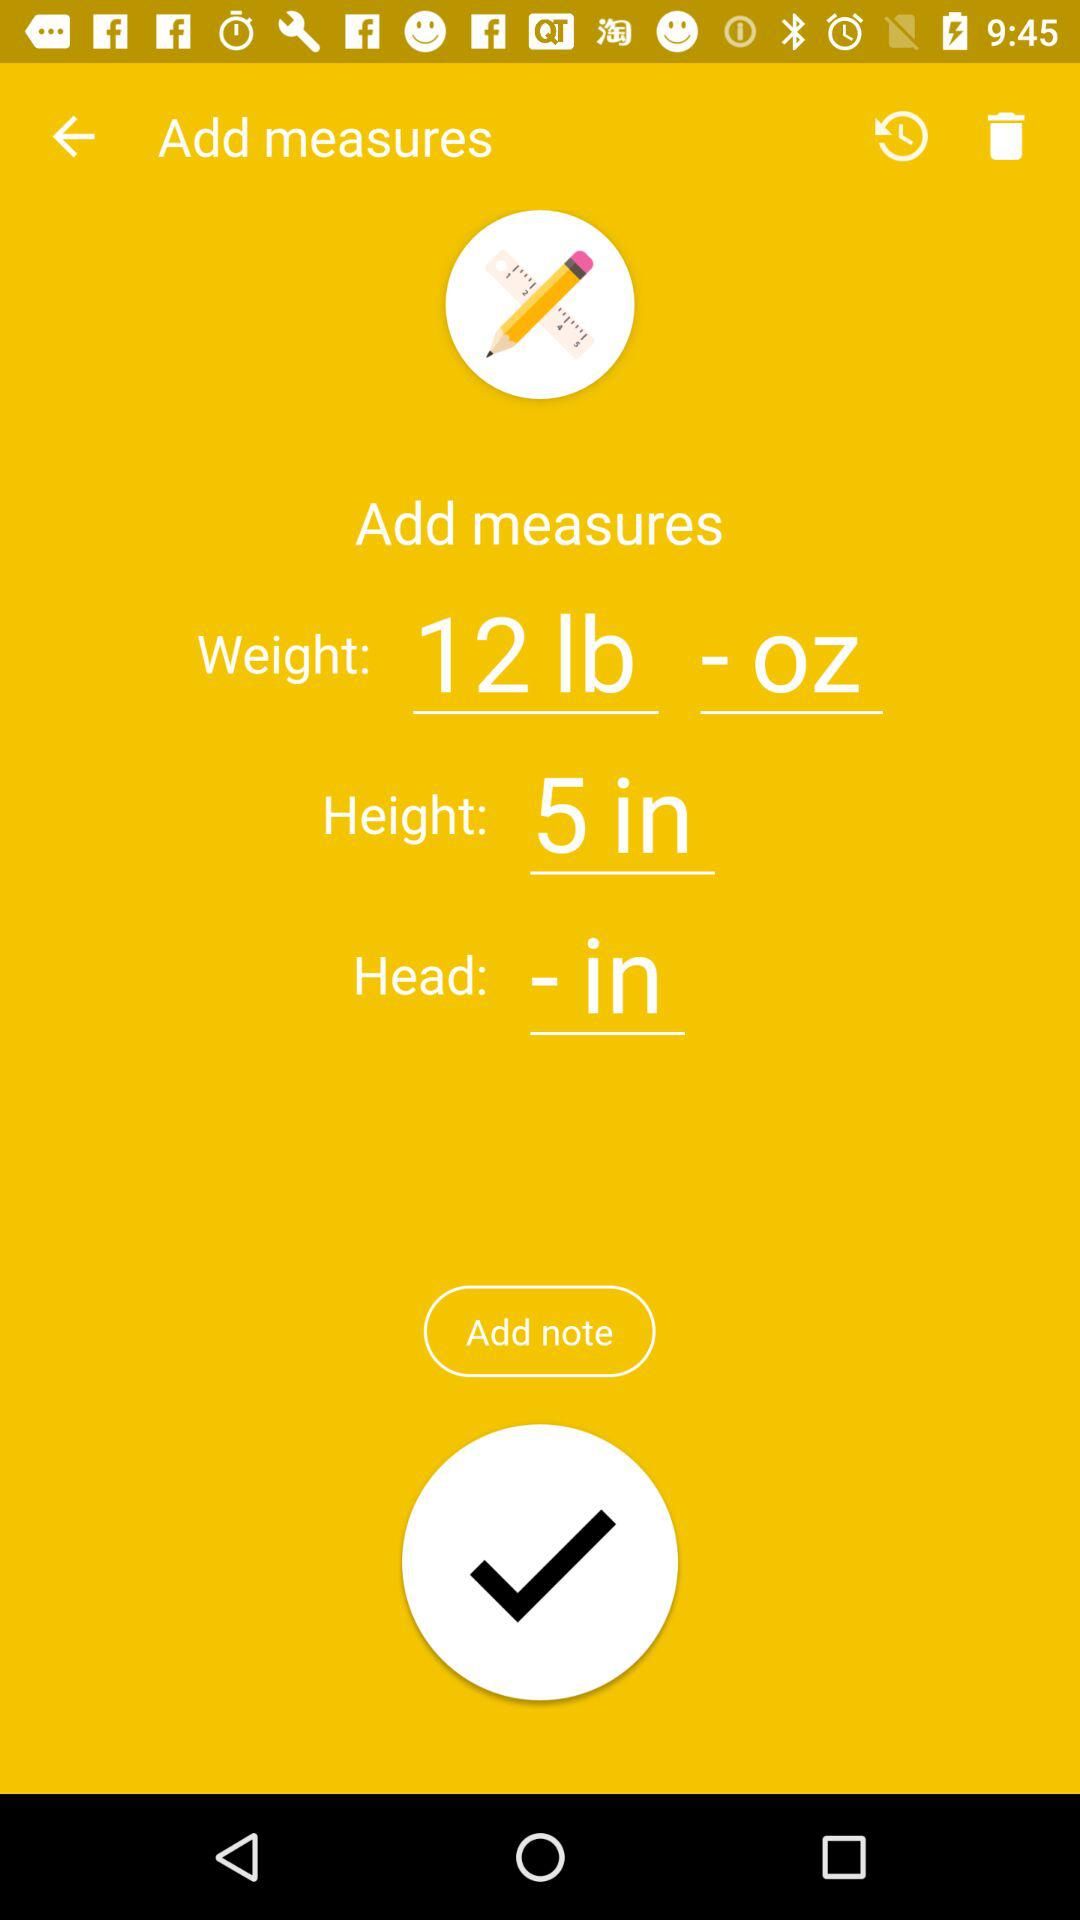How many pounds are there in the weight measurement?
Answer the question using a single word or phrase. 12 